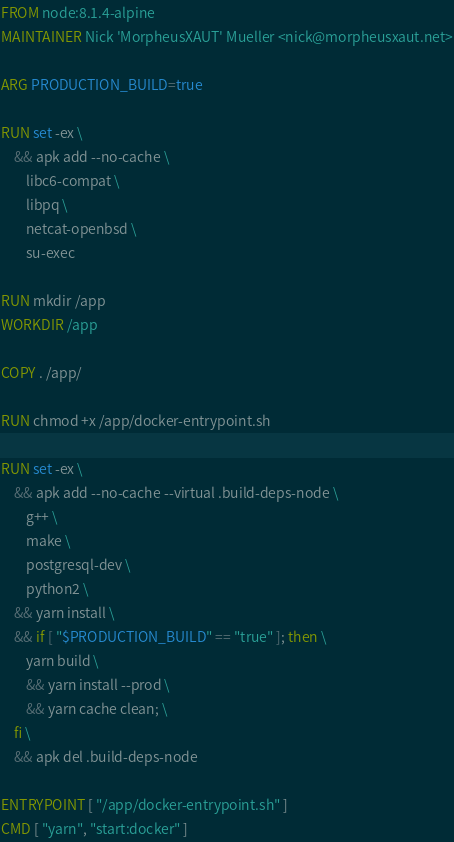Convert code to text. <code><loc_0><loc_0><loc_500><loc_500><_Dockerfile_>FROM node:8.1.4-alpine
MAINTAINER Nick 'MorpheusXAUT' Mueller <nick@morpheusxaut.net>

ARG PRODUCTION_BUILD=true

RUN set -ex \
    && apk add --no-cache \
        libc6-compat \
        libpq \
        netcat-openbsd \
        su-exec

RUN mkdir /app
WORKDIR /app

COPY . /app/

RUN chmod +x /app/docker-entrypoint.sh

RUN set -ex \
    && apk add --no-cache --virtual .build-deps-node \
        g++ \
        make \
        postgresql-dev \
        python2 \
    && yarn install \
    && if [ "$PRODUCTION_BUILD" == "true" ]; then \
        yarn build \
        && yarn install --prod \
        && yarn cache clean; \
    fi \
    && apk del .build-deps-node

ENTRYPOINT [ "/app/docker-entrypoint.sh" ]
CMD [ "yarn", "start:docker" ]</code> 